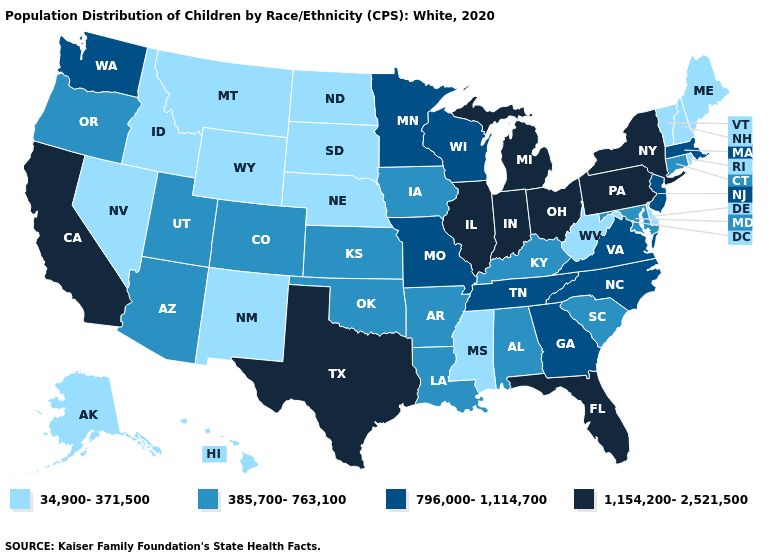What is the value of Massachusetts?
Give a very brief answer. 796,000-1,114,700. Does South Dakota have the lowest value in the MidWest?
Keep it brief. Yes. Which states have the lowest value in the MidWest?
Short answer required. Nebraska, North Dakota, South Dakota. What is the value of Indiana?
Give a very brief answer. 1,154,200-2,521,500. Among the states that border South Dakota , which have the highest value?
Give a very brief answer. Minnesota. Which states have the highest value in the USA?
Be succinct. California, Florida, Illinois, Indiana, Michigan, New York, Ohio, Pennsylvania, Texas. Which states have the lowest value in the USA?
Keep it brief. Alaska, Delaware, Hawaii, Idaho, Maine, Mississippi, Montana, Nebraska, Nevada, New Hampshire, New Mexico, North Dakota, Rhode Island, South Dakota, Vermont, West Virginia, Wyoming. What is the lowest value in the South?
Keep it brief. 34,900-371,500. What is the lowest value in the USA?
Give a very brief answer. 34,900-371,500. What is the value of Wyoming?
Quick response, please. 34,900-371,500. Does Florida have a lower value than Illinois?
Concise answer only. No. What is the highest value in the MidWest ?
Give a very brief answer. 1,154,200-2,521,500. Name the states that have a value in the range 385,700-763,100?
Quick response, please. Alabama, Arizona, Arkansas, Colorado, Connecticut, Iowa, Kansas, Kentucky, Louisiana, Maryland, Oklahoma, Oregon, South Carolina, Utah. Which states have the highest value in the USA?
Answer briefly. California, Florida, Illinois, Indiana, Michigan, New York, Ohio, Pennsylvania, Texas. 